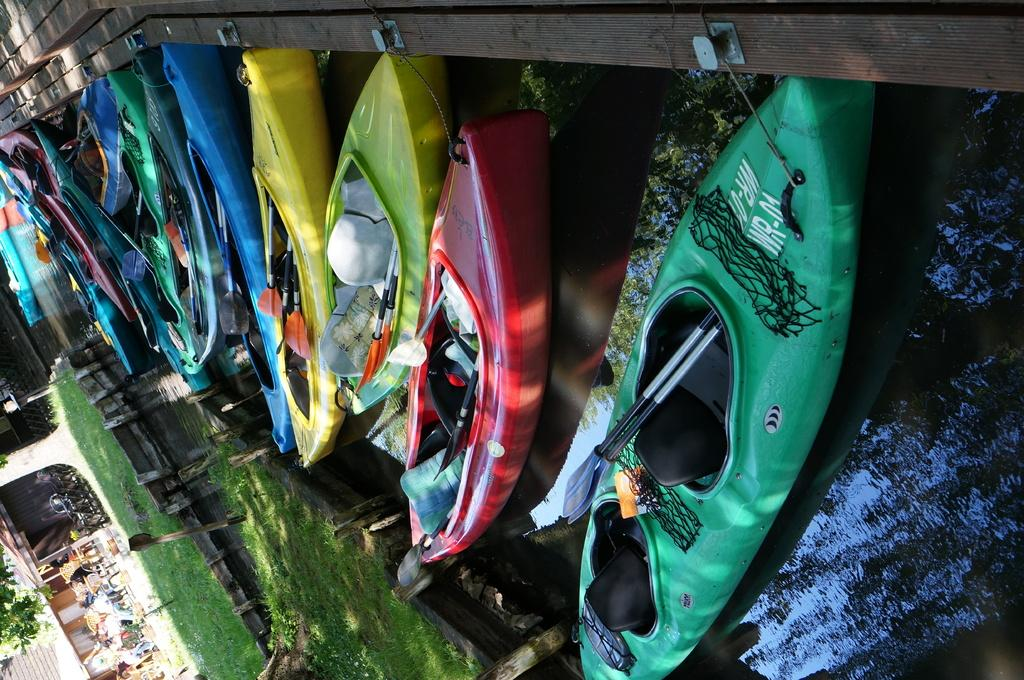What type of vehicles are in the image? There are colorful boats in the image. Where are the boats located? The boats are on water. What type of terrain is visible in the image? There is grass visible on the ground. What type of prose can be seen on the boats in the image? There is no prose visible on the boats in the image. What type of ornament is hanging from the elbow of the person in the image? There is no person or elbow present in the image. 